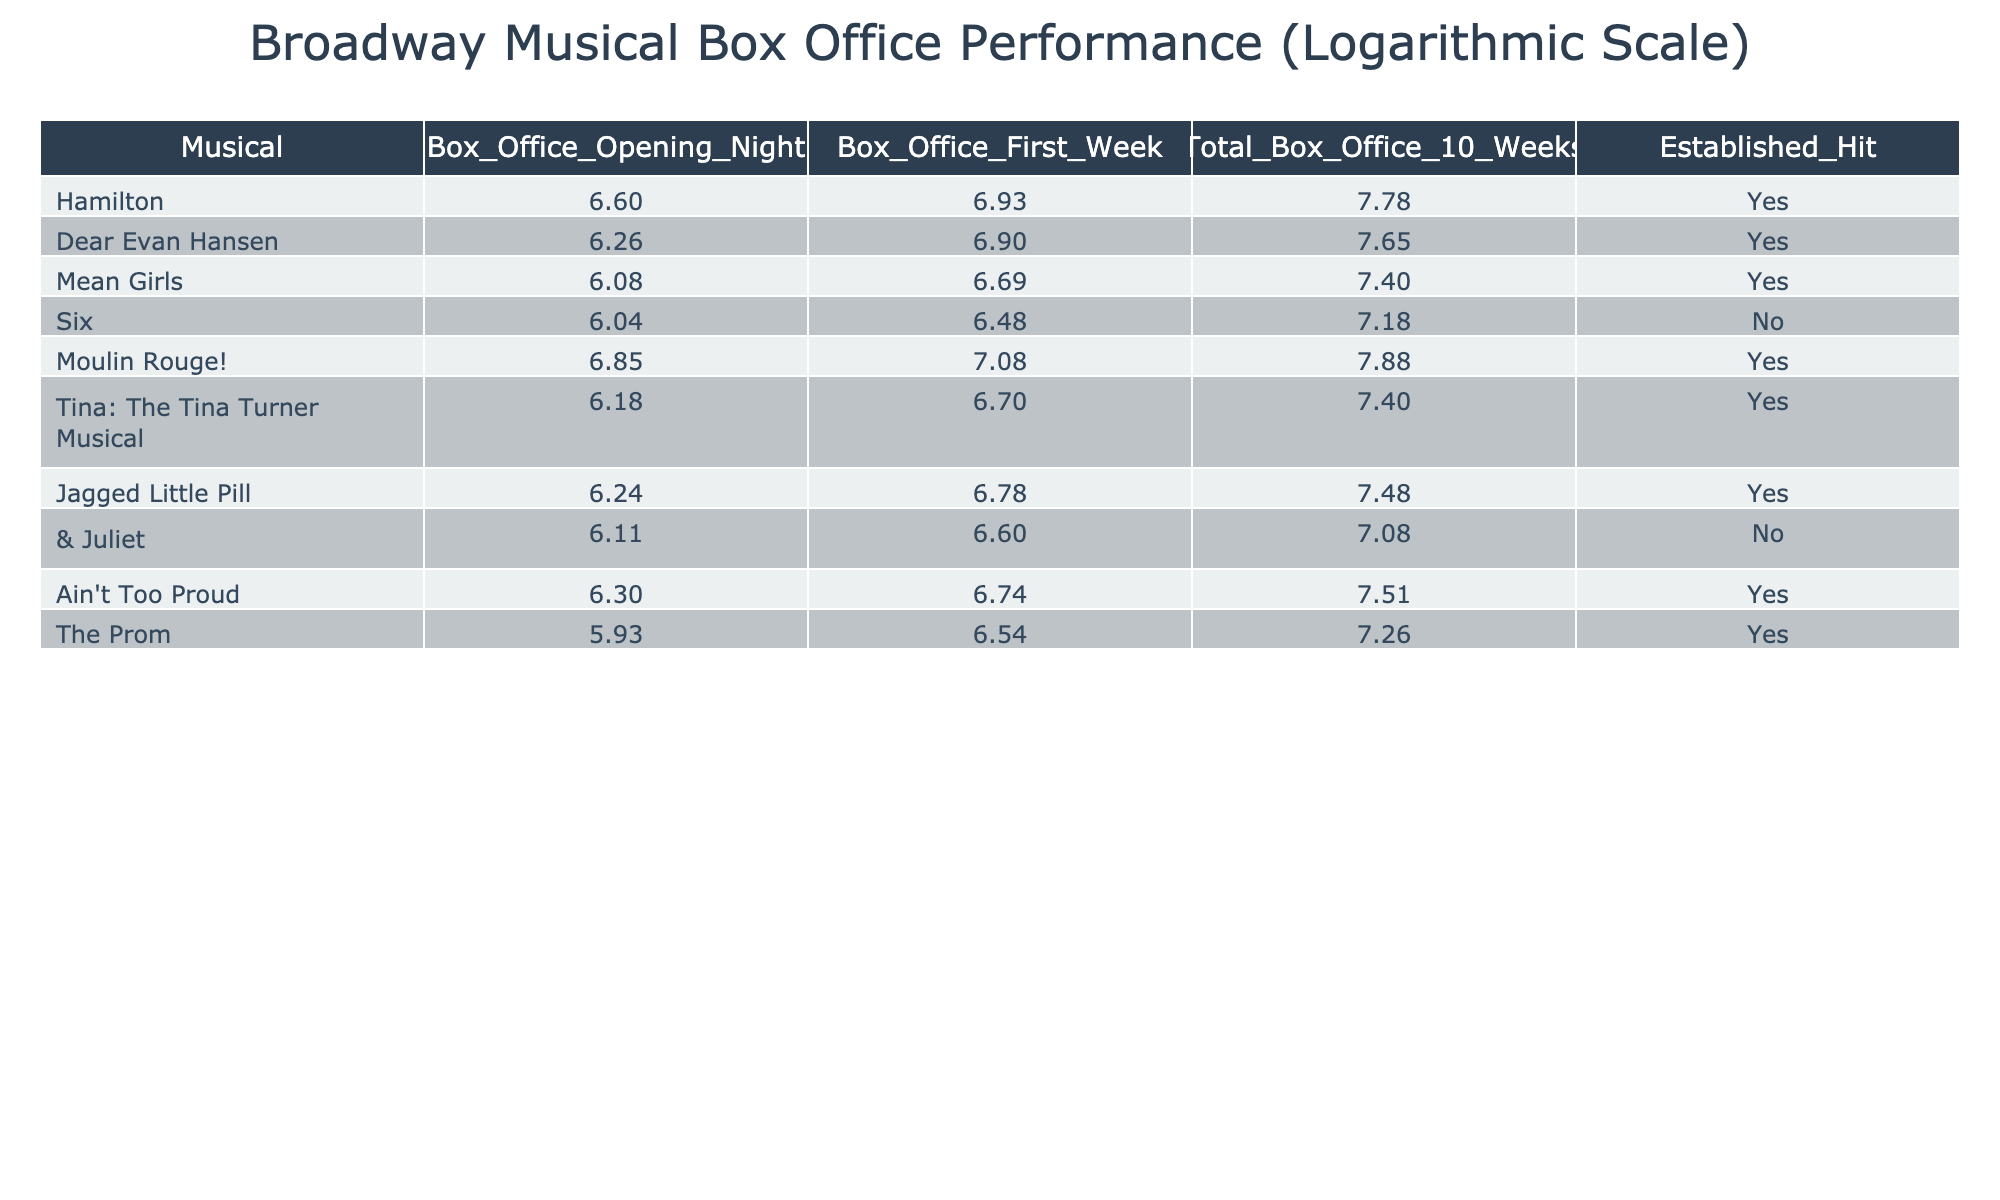What is the total box office for "Hamilton" after 10 weeks? The table indicates that "Hamilton" has a total box office of 60000000 after 10 weeks.
Answer: 60000000 Which musical had the highest box office on opening night? By comparing the 'Box_Office_Opening_Night' values, "Moulin Rouge!" has the highest value at 7000000.
Answer: 7000000 Is "Six" an established hit? Referring to the 'Established_Hit' column, "Six" is marked as 'No', indicating it is not an established hit.
Answer: No What is the average box office for the first week among the established hits? First, I sum the first week box office values for established hits: 8500000 (Hamilton) + 8000000 (Dear Evan Hansen) + 4950000 (Mean Girls) + 12000000 (Moulin Rouge!) + 5000000 (Tina: The Tina Turner Musical) + 6000000 (Jagged Little Pill) + 5500000 (Ain't Too Proud) + 3500000 (The Prom) = 49500000. Then, I divide by the count of established hits, which is 8. So, the average is 49500000 / 8 = 6187500.
Answer: 6187500 Which musical had the lowest total box office after 10 weeks? Comparing the 'Total_Box_Office_10_Weeks' column, "Six" has the lowest total box office at 15000000.
Answer: 15000000 What is the difference in the box office opening night between "Dear Evan Hansen" and "Mean Girls"? "Dear Evan Hansen" has an opening night box office of 1800000, while "Mean Girls" has 1200000. The difference is 1800000 - 1200000 = 600000.
Answer: 600000 Which musical has a first week box office greater than 6000000 and is not an established hit? "Six" has a first week box office of 3000000, while "& Juliet" has a first week box office of 4000000. Both are less than 6000000. Hence, there are no musicals satisfying the criteria.
Answer: None What is the total box office for "Ain't Too Proud" and "The Prom" after 10 weeks? First, I check the total box office of each musical: "Ain't Too Proud" has 32000000 and "The Prom" has 18000000. Adding both gives 32000000 + 18000000 = 50000000.
Answer: 50000000 